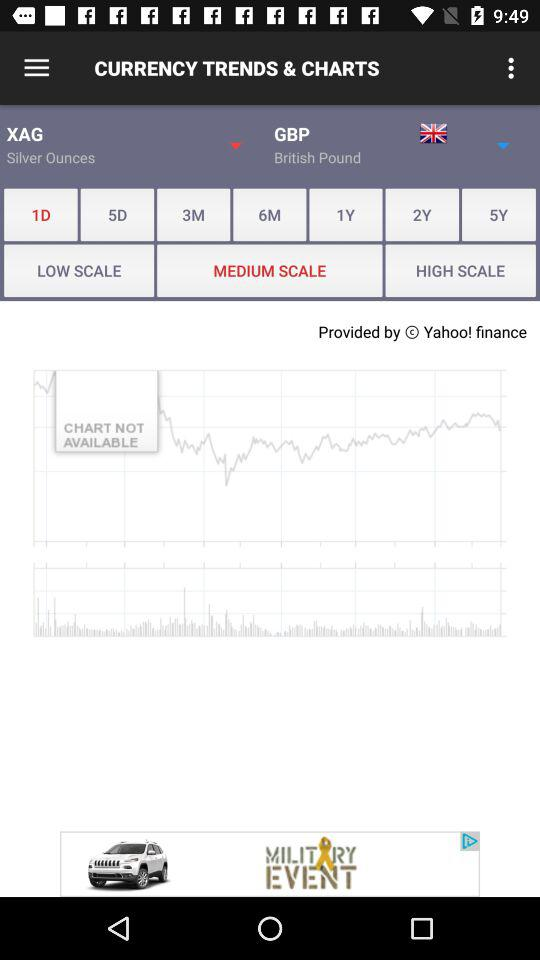What is the currency trend of silver ounces in British Pound?
When the provided information is insufficient, respond with <no answer>. <no answer> 